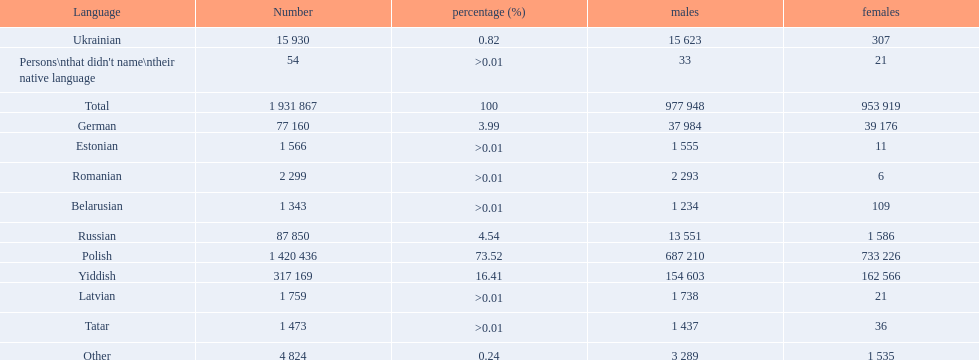How many languages are there? Polish, Yiddish, Russian, German, Ukrainian, Romanian, Latvian, Estonian, Tatar, Belarusian. Which language do more people speak? Polish. 